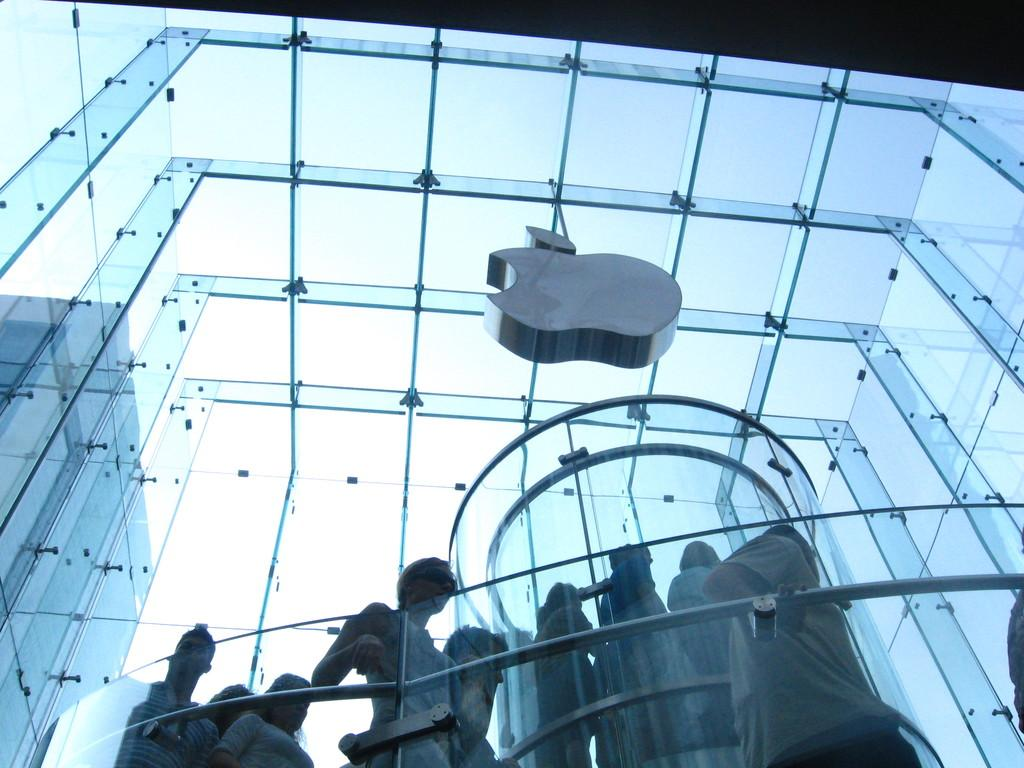What type of building is featured in the image? There is a glass building in the image. What can be seen through the glass of the first building? Another building is visible through the glass of the first building. Are there any people present in the image? Yes, there are people standing in the image. What is the color of the sky in the image? The sky is blue in the image. What type of alarm can be heard going off in the image? There is no alarm present or audible in the image. What shape are the sticks used by the people in the image? There are no sticks present in the image. 